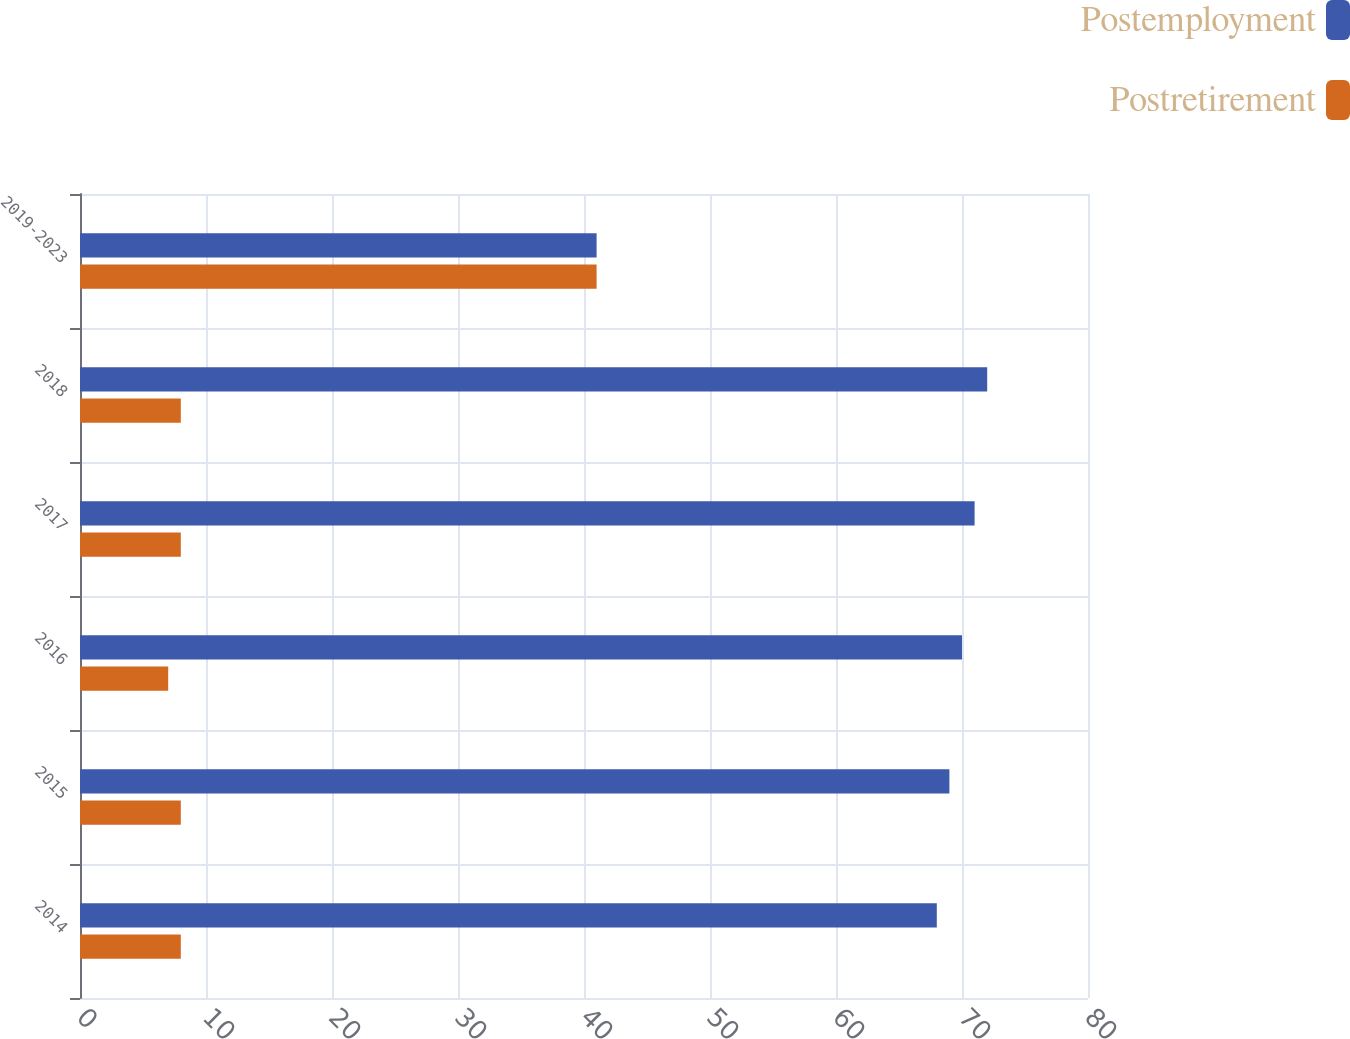<chart> <loc_0><loc_0><loc_500><loc_500><stacked_bar_chart><ecel><fcel>2014<fcel>2015<fcel>2016<fcel>2017<fcel>2018<fcel>2019-2023<nl><fcel>Postemployment<fcel>68<fcel>69<fcel>70<fcel>71<fcel>72<fcel>41<nl><fcel>Postretirement<fcel>8<fcel>8<fcel>7<fcel>8<fcel>8<fcel>41<nl></chart> 